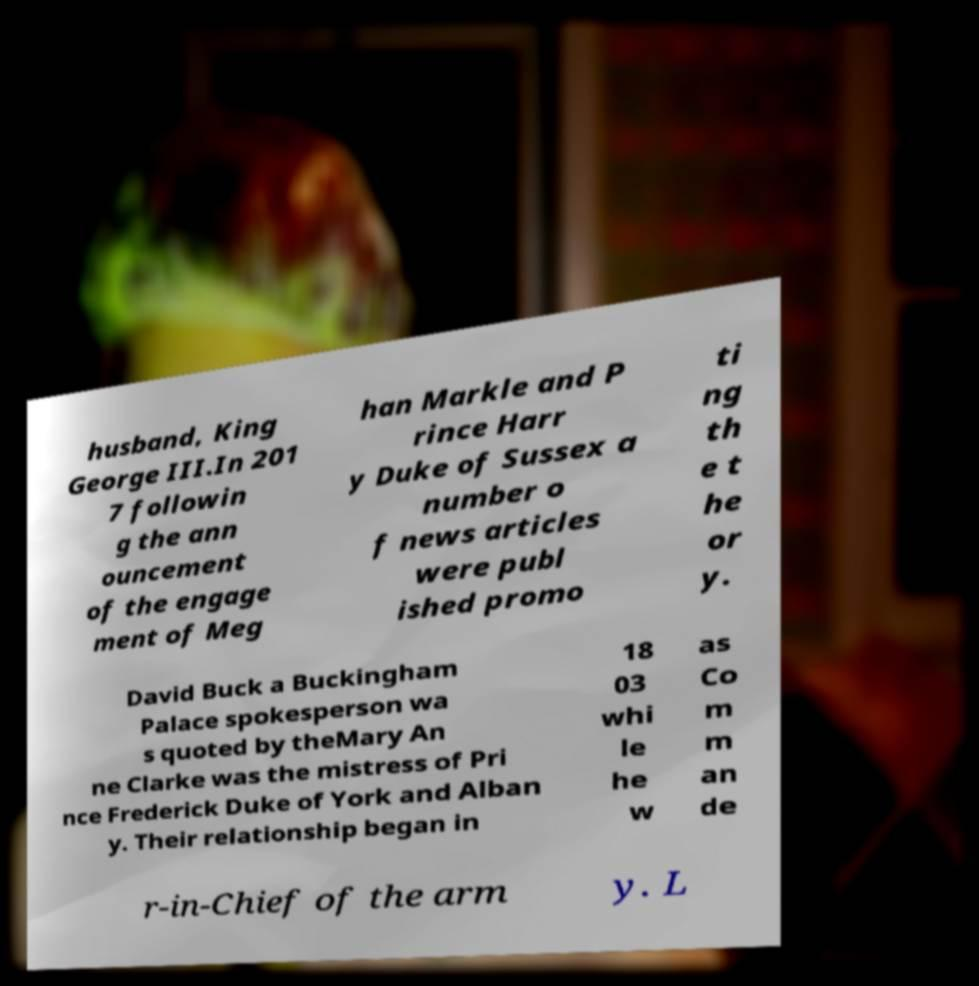There's text embedded in this image that I need extracted. Can you transcribe it verbatim? husband, King George III.In 201 7 followin g the ann ouncement of the engage ment of Meg han Markle and P rince Harr y Duke of Sussex a number o f news articles were publ ished promo ti ng th e t he or y. David Buck a Buckingham Palace spokesperson wa s quoted by theMary An ne Clarke was the mistress of Pri nce Frederick Duke of York and Alban y. Their relationship began in 18 03 whi le he w as Co m m an de r-in-Chief of the arm y. L 